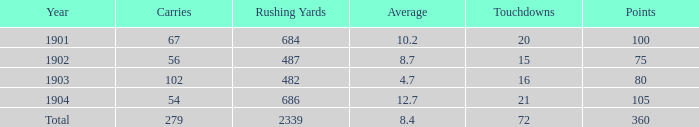7 and a count of 72 touchdowns? 1.0. 